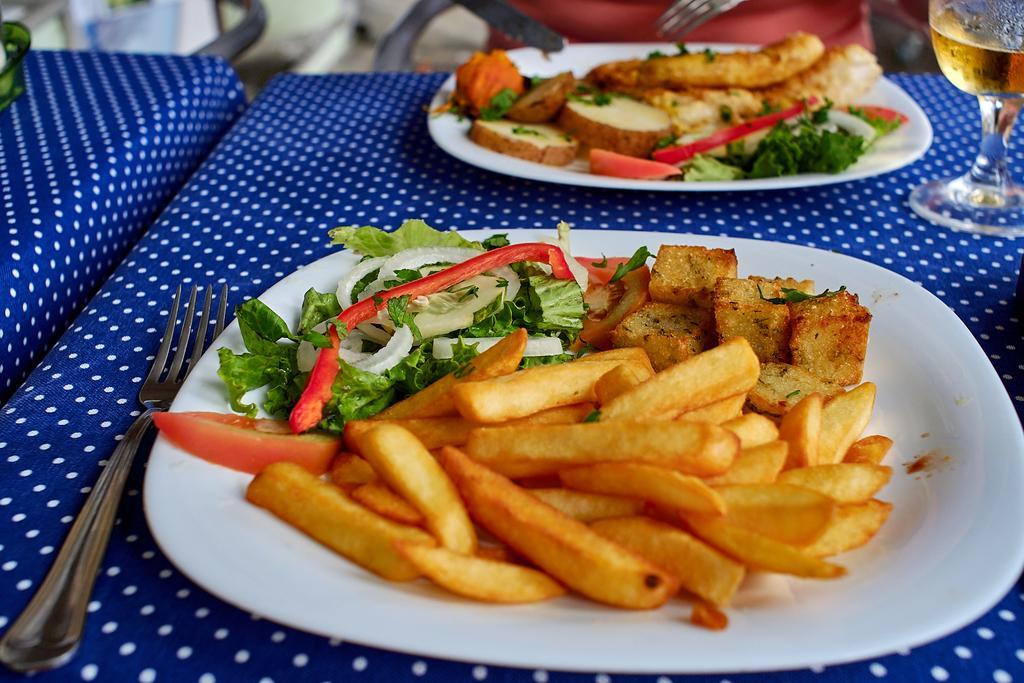Describe this image in one or two sentences. In the picture I can see the tables which are covered with blue color cloth. I can see the plates and a glass on the table. I can see the french fries on the plate. There is a fork on the table. 